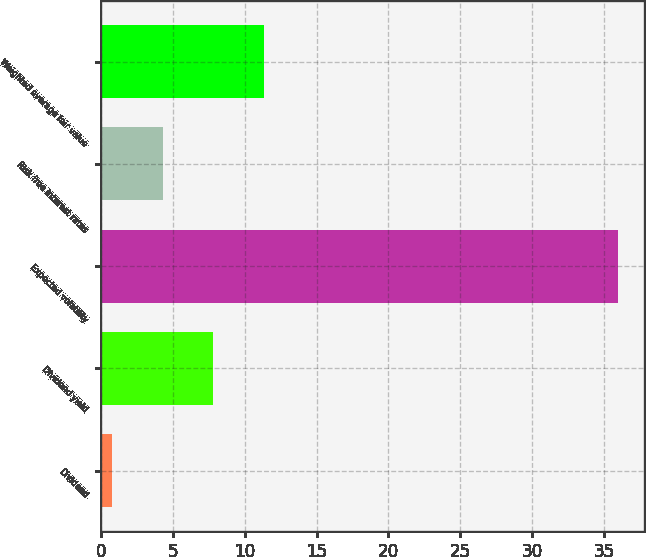Convert chart. <chart><loc_0><loc_0><loc_500><loc_500><bar_chart><fcel>Dividend<fcel>Dividend yield<fcel>Expected volatility<fcel>Risk free interest rates<fcel>Weighted average fair value<nl><fcel>0.75<fcel>7.81<fcel>36<fcel>4.28<fcel>11.34<nl></chart> 